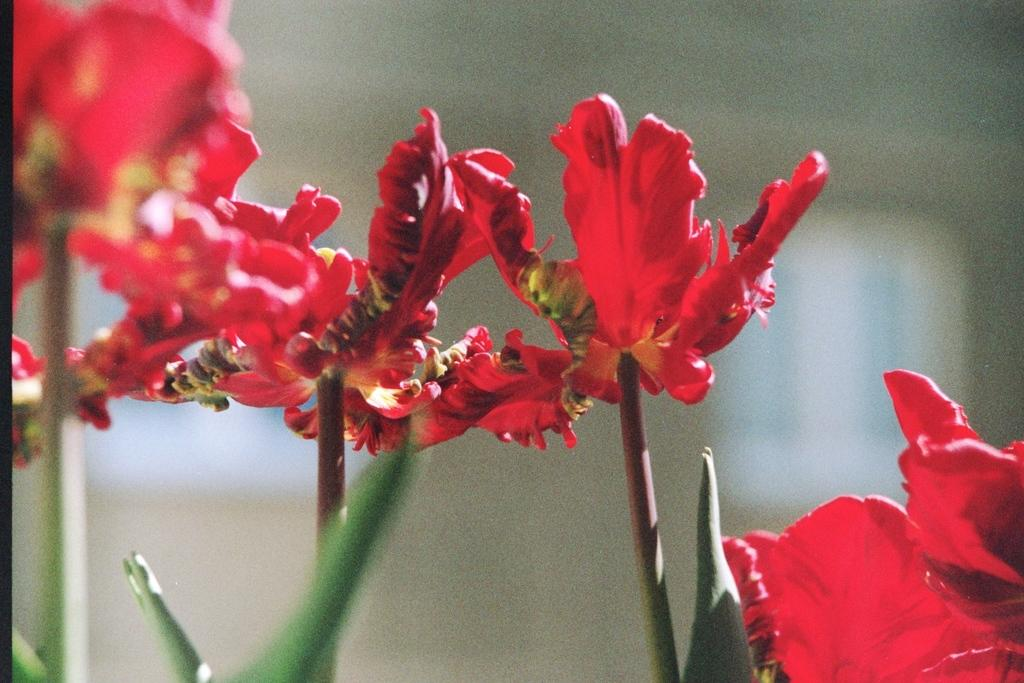What type of plants can be seen in the image? There are flowers in the image. What parts of the flowers are visible? The flowers have stems. What else can be seen at the bottom of the image? There are leaves at the bottom of the image. How would you describe the background of the image? The background of the image is blurry. Who is the owner of the protest in the image? There is no protest present in the image, so there is no owner to identify. 